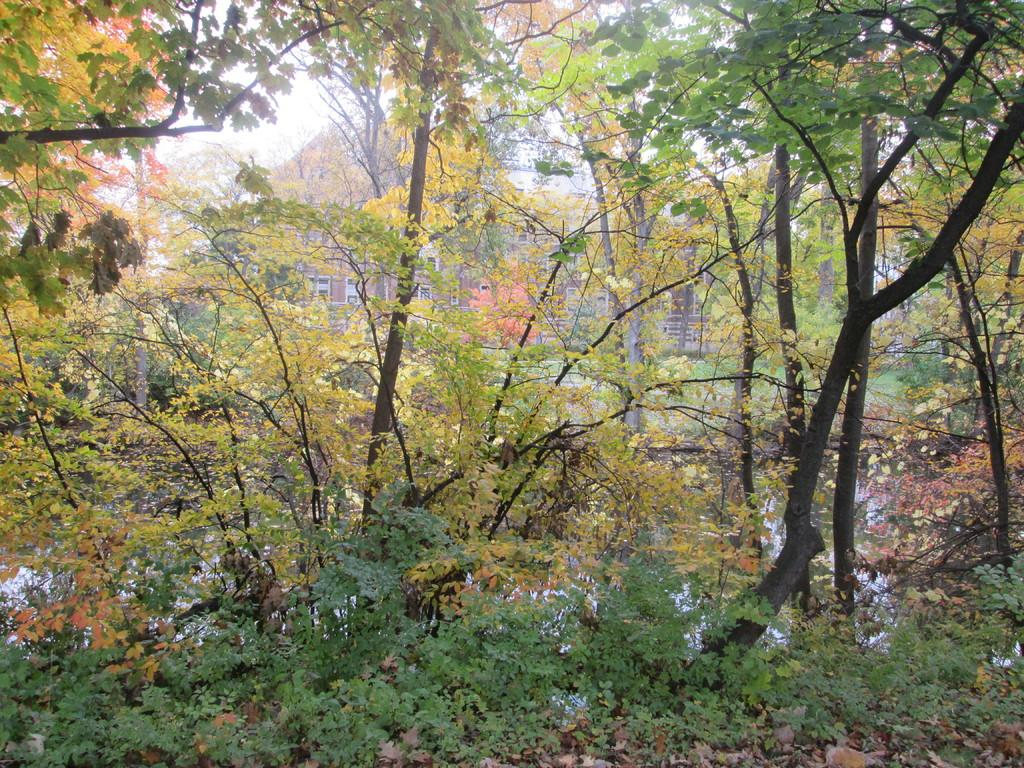What type of vegetation is present in the image? There are green trees in the image. How many frogs can be seen sitting on the furniture in the image? There are no frogs or furniture present in the image; it only features green trees. 